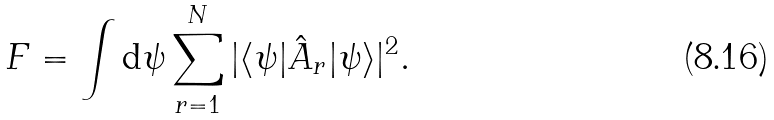Convert formula to latex. <formula><loc_0><loc_0><loc_500><loc_500>F = \int \text {d} \psi \sum _ { r = 1 } ^ { N } | \langle \psi | \hat { A } _ { r } | \psi \rangle | ^ { 2 } .</formula> 